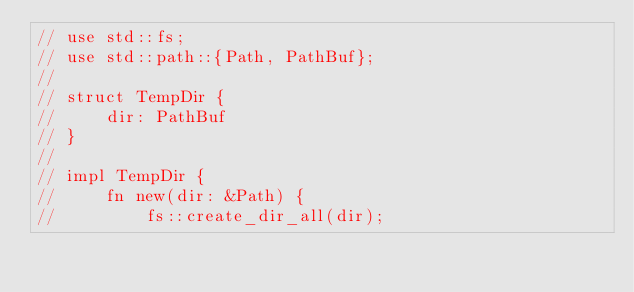<code> <loc_0><loc_0><loc_500><loc_500><_Rust_>// use std::fs;
// use std::path::{Path, PathBuf};
//
// struct TempDir {
//     dir: PathBuf
// }
//
// impl TempDir {
//     fn new(dir: &Path) {
//         fs::create_dir_all(dir);</code> 